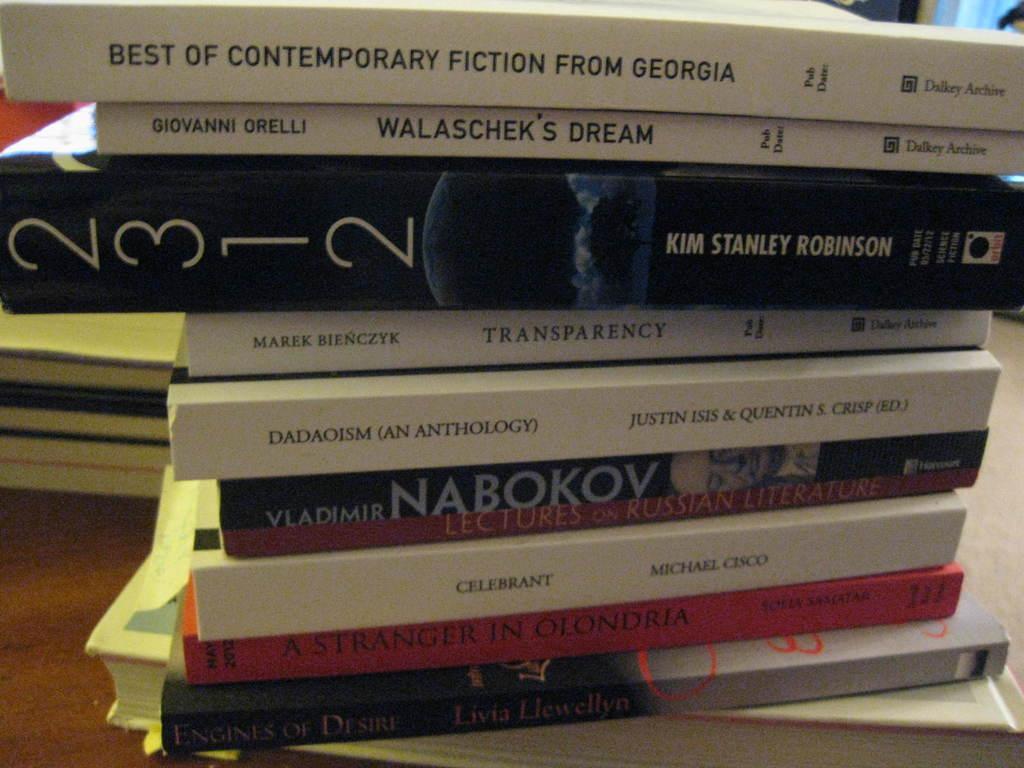Can you describe this image briefly? In this image I can see dozens of books on the floor. This image is taken may be in a hall. 